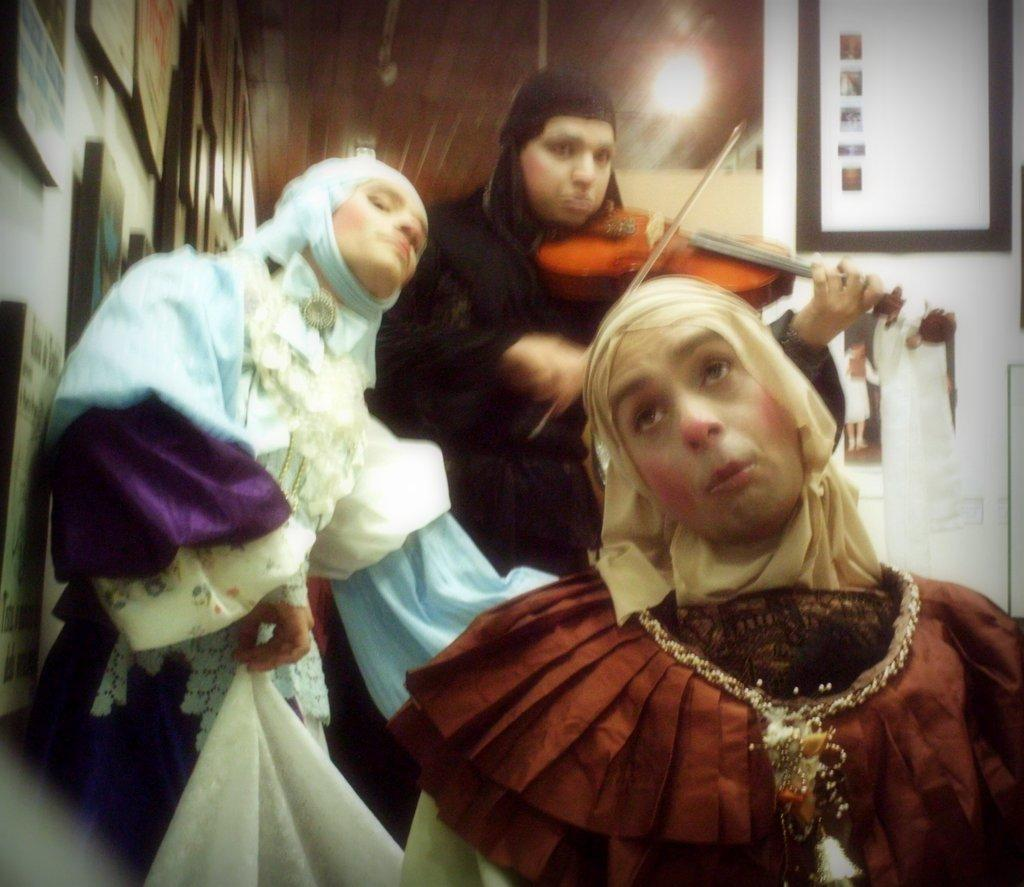How many people are in the image? There are people in the image, but the exact number is not specified. What is one person holding in the image? One person is holding a violin in the image. What can be seen on the wall in the image? There are frames on the wall in the image. What type of receipt is visible on the wall in the image? There is no receipt visible on the wall in the image. What design elements can be seen on the frames on the wall? The facts provided do not mention any design elements on the frames, so we cannot answer this question based on the given information. 